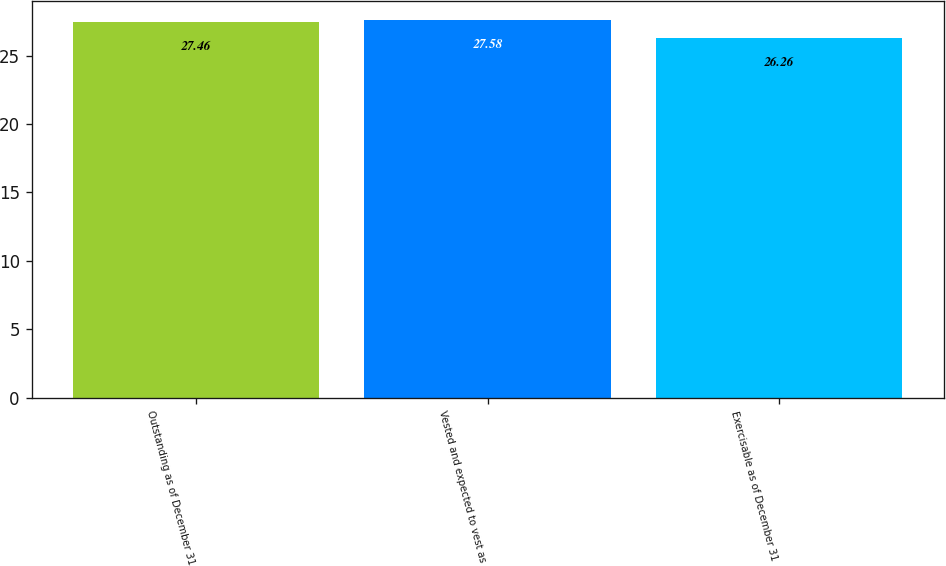Convert chart to OTSL. <chart><loc_0><loc_0><loc_500><loc_500><bar_chart><fcel>Outstanding as of December 31<fcel>Vested and expected to vest as<fcel>Exercisable as of December 31<nl><fcel>27.46<fcel>27.58<fcel>26.26<nl></chart> 